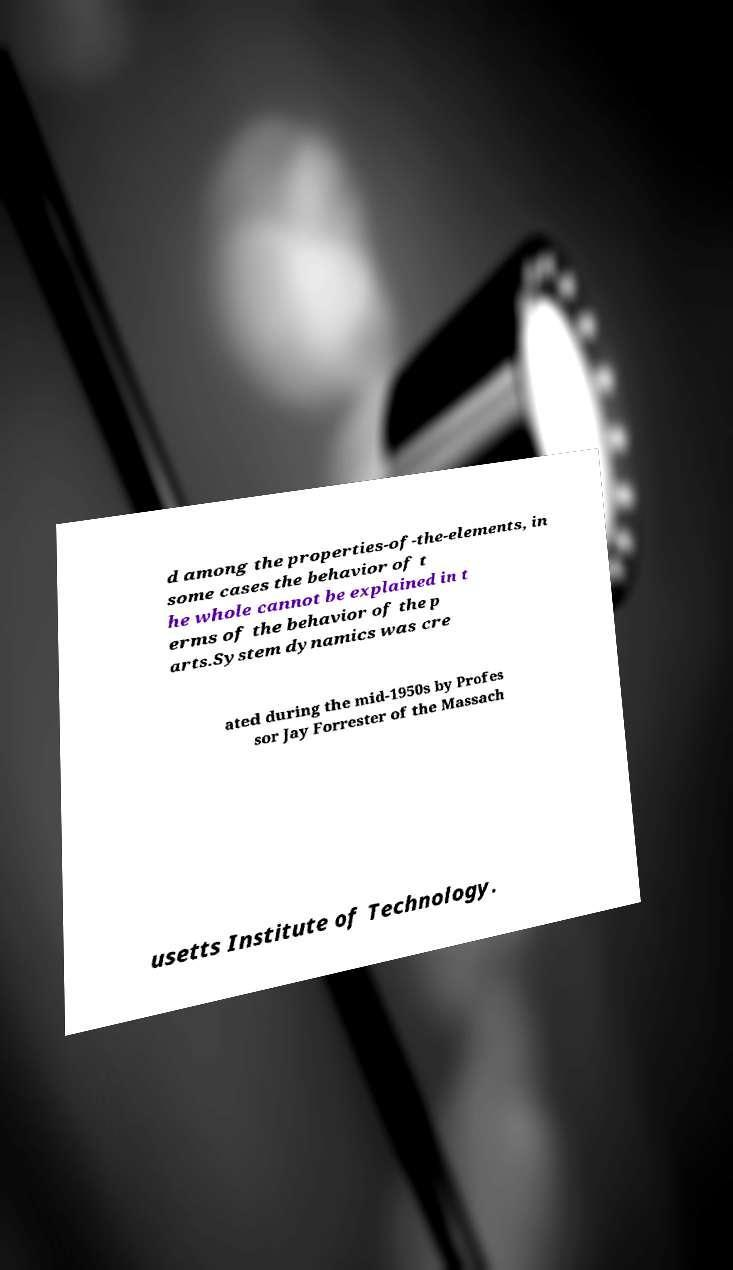There's text embedded in this image that I need extracted. Can you transcribe it verbatim? d among the properties-of-the-elements, in some cases the behavior of t he whole cannot be explained in t erms of the behavior of the p arts.System dynamics was cre ated during the mid-1950s by Profes sor Jay Forrester of the Massach usetts Institute of Technology. 